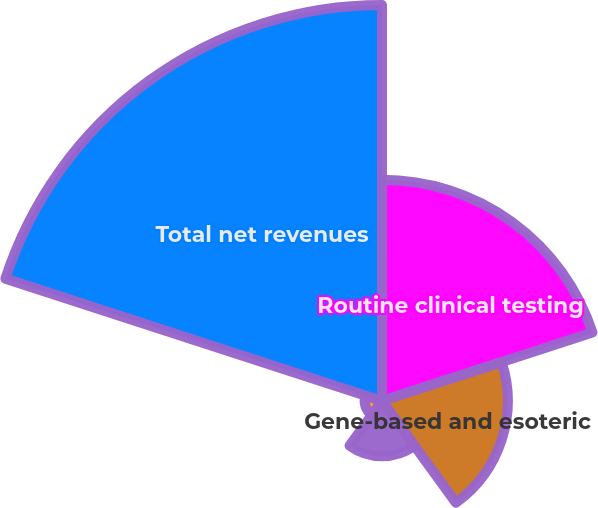Convert chart. <chart><loc_0><loc_0><loc_500><loc_500><pie_chart><fcel>Routine clinical testing<fcel>Gene-based and esoteric<fcel>Anatomic pathology testing<fcel>All other<fcel>Total net revenues<nl><fcel>27.13%<fcel>15.42%<fcel>6.77%<fcel>2.13%<fcel>48.54%<nl></chart> 